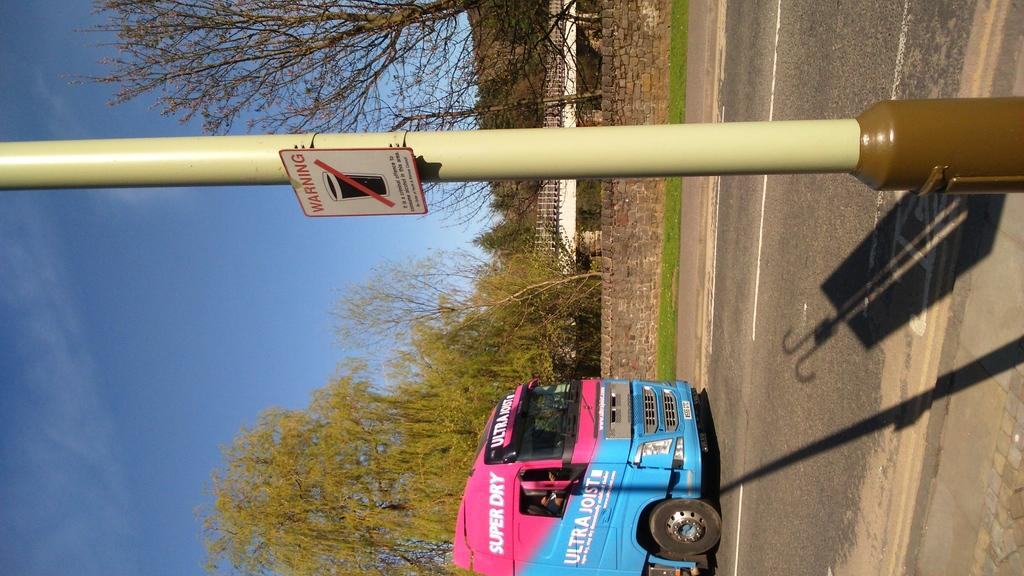<image>
Render a clear and concise summary of the photo. A pink and blue Super Dry vehicle drives down the road. 